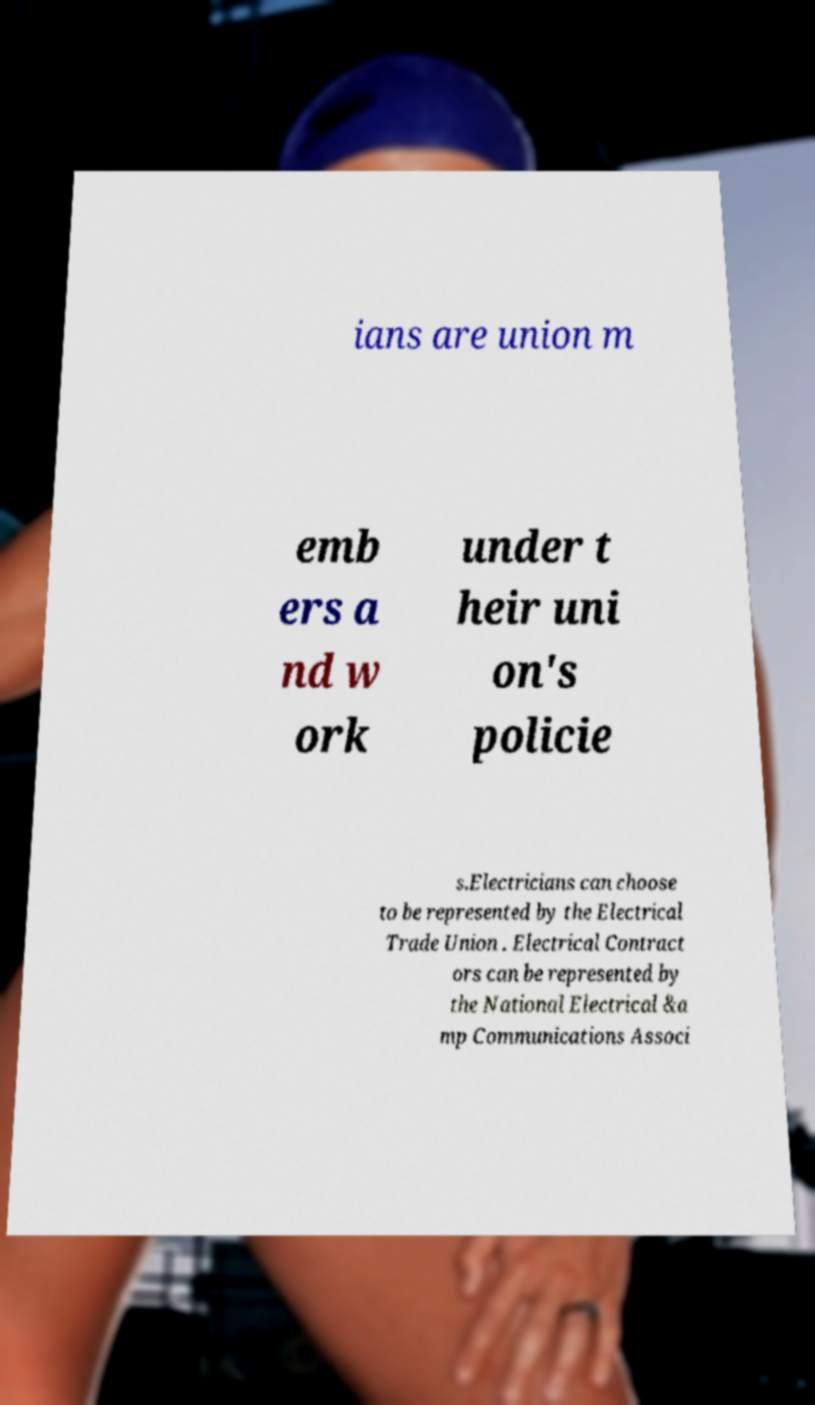I need the written content from this picture converted into text. Can you do that? ians are union m emb ers a nd w ork under t heir uni on's policie s.Electricians can choose to be represented by the Electrical Trade Union . Electrical Contract ors can be represented by the National Electrical &a mp Communications Associ 